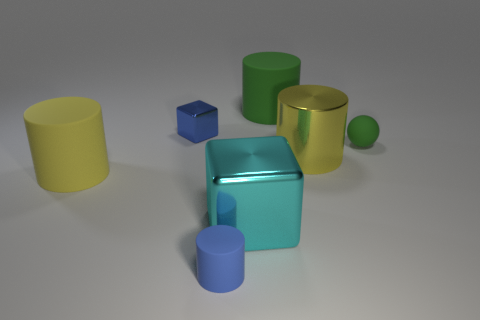There is a blue object that is behind the tiny green object; is it the same shape as the large yellow object that is to the left of the tiny cylinder?
Your response must be concise. No. The cyan metallic block is what size?
Your response must be concise. Large. What material is the cube to the right of the cylinder in front of the yellow object that is in front of the large metallic cylinder made of?
Your answer should be compact. Metal. How many other things are there of the same color as the tiny matte sphere?
Your answer should be very brief. 1. What number of yellow things are either big metallic cylinders or large cylinders?
Your response must be concise. 2. What material is the block to the right of the blue block?
Make the answer very short. Metal. Is the cube that is behind the big cyan cube made of the same material as the tiny sphere?
Make the answer very short. No. What shape is the large green matte object?
Offer a very short reply. Cylinder. There is a large cylinder that is behind the metallic object that is to the left of the blue cylinder; what number of tiny blue matte things are behind it?
Give a very brief answer. 0. What number of other objects are the same material as the cyan object?
Provide a short and direct response. 2. 